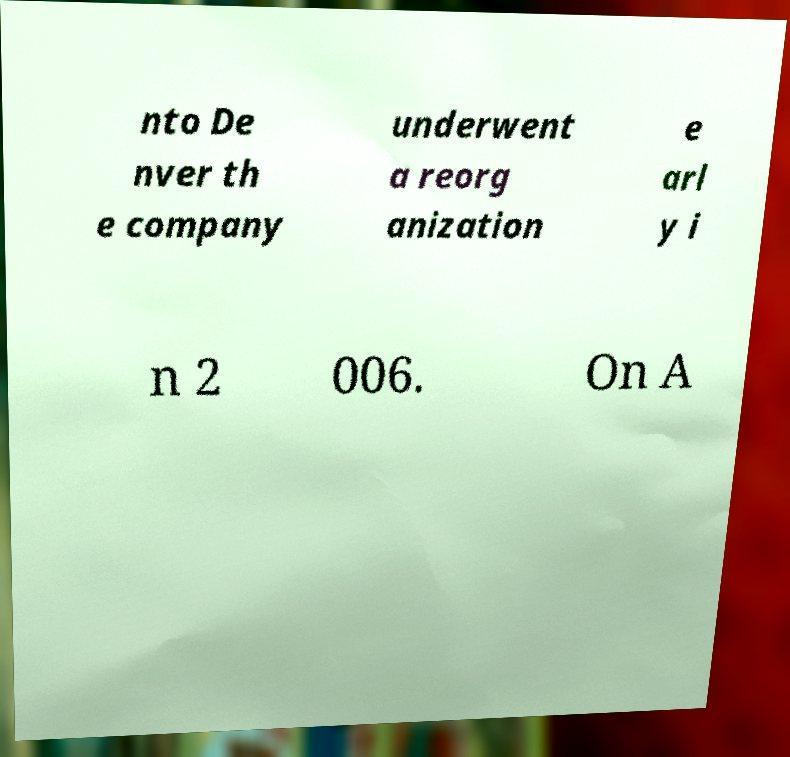I need the written content from this picture converted into text. Can you do that? nto De nver th e company underwent a reorg anization e arl y i n 2 006. On A 